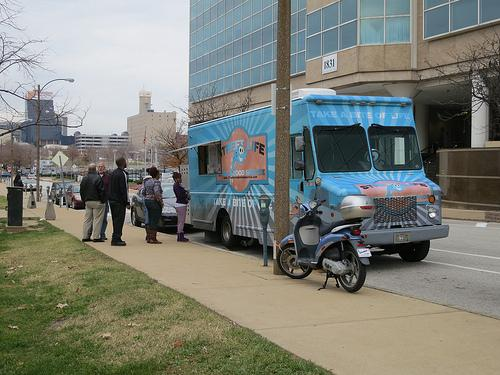Describe the setting of the image in a simple manner. A busy street scene near a food truck, a tall building, and a parked scooter with various people around. Provide a brief description of the image focusing on the main elements. A blue food truck is parked near a tall building with people lining up, while a man in a black jacket talks to a woman in purple pants and a scooter parked on the sidewalk. Mention the human activities happening in the image. People are lining up for food, talking to each other, and waiting by the sidewalk near a parked scooter. Using a casual language, talk about what is happening in the image. Some folks are lining up for tasty grub from that blue food truck, while others are just chatting and chilling by a scooter on the sidewalk. Focus on the transportation elements seen in the image. A blue food truck is parked by the sidewalk, near a blue motor scooter, and some visible cars in the distance. Describe the image focusing on the atmosphere and vibe it gives. The image captures a busy and lively urban scene with people engaging and waiting to be served by a colorful food truck, while a scooter is parked nearby. Mention the details about the people in the image. A man with a black jacket and a woman with purple pants are talking, while other people are standing and waiting in line for the food truck. Narrate the scene in the image using a poetic style. In a cityscape where skies are gray, a blue truck serves food as people gather and stay. Scooter idle waits, as chatter resonates, a tapestry of urban life at play. Provide a concise summary of the main objects in the image. Blue food truck, people queuing, talking, and waiting, tall building, scooter, and a streetlamp. Mention the prominent colors and objects seen in the image. Blue motor scooter and truck, green grass patch, tall street light, orange sign, paved sidewalk, tall multi-story building, and people standing around. 